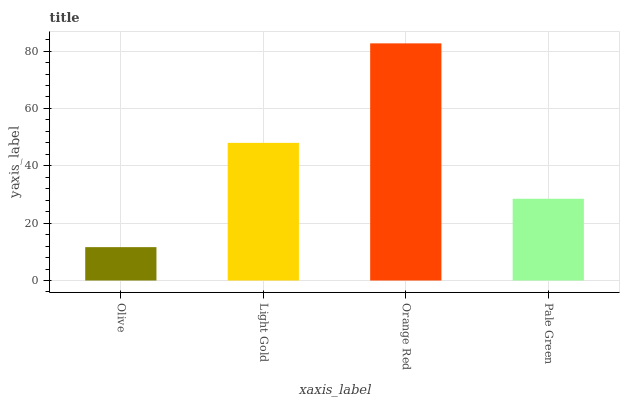Is Olive the minimum?
Answer yes or no. Yes. Is Orange Red the maximum?
Answer yes or no. Yes. Is Light Gold the minimum?
Answer yes or no. No. Is Light Gold the maximum?
Answer yes or no. No. Is Light Gold greater than Olive?
Answer yes or no. Yes. Is Olive less than Light Gold?
Answer yes or no. Yes. Is Olive greater than Light Gold?
Answer yes or no. No. Is Light Gold less than Olive?
Answer yes or no. No. Is Light Gold the high median?
Answer yes or no. Yes. Is Pale Green the low median?
Answer yes or no. Yes. Is Orange Red the high median?
Answer yes or no. No. Is Olive the low median?
Answer yes or no. No. 